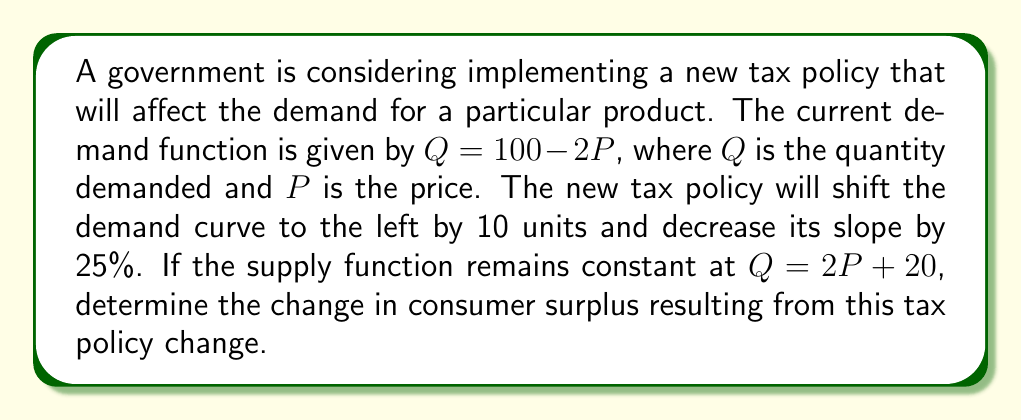What is the answer to this math problem? 1. First, let's determine the new demand function after the tax policy change:
   - Shift left by 10 units: $Q = 90 - 2P$
   - Decrease slope by 25%: New slope = $2 * 0.75 = 1.5$
   - New demand function: $Q = 90 - 1.5P$

2. Find the equilibrium points for both scenarios:
   - Original: $100 - 2P = 2P + 20$
     Solving this: $P = 20$, $Q = 60$
   - New: $90 - 1.5P = 2P + 20$
     Solving this: $P = 20$, $Q = 60$

3. Calculate consumer surplus for both scenarios:
   - Consumer surplus is the area between the demand curve and the equilibrium price
   - Original CS: $\frac{1}{2} * (50 - 20) * 60 = 900$
   - New CS: $\frac{1}{2} * (60 - 20) * 60 = 1200$

4. Calculate the change in consumer surplus:
   $\text{Change in CS} = 1200 - 900 = 300$

Therefore, the tax policy change results in an increase of 300 units in consumer surplus.
Answer: 300 units increase 